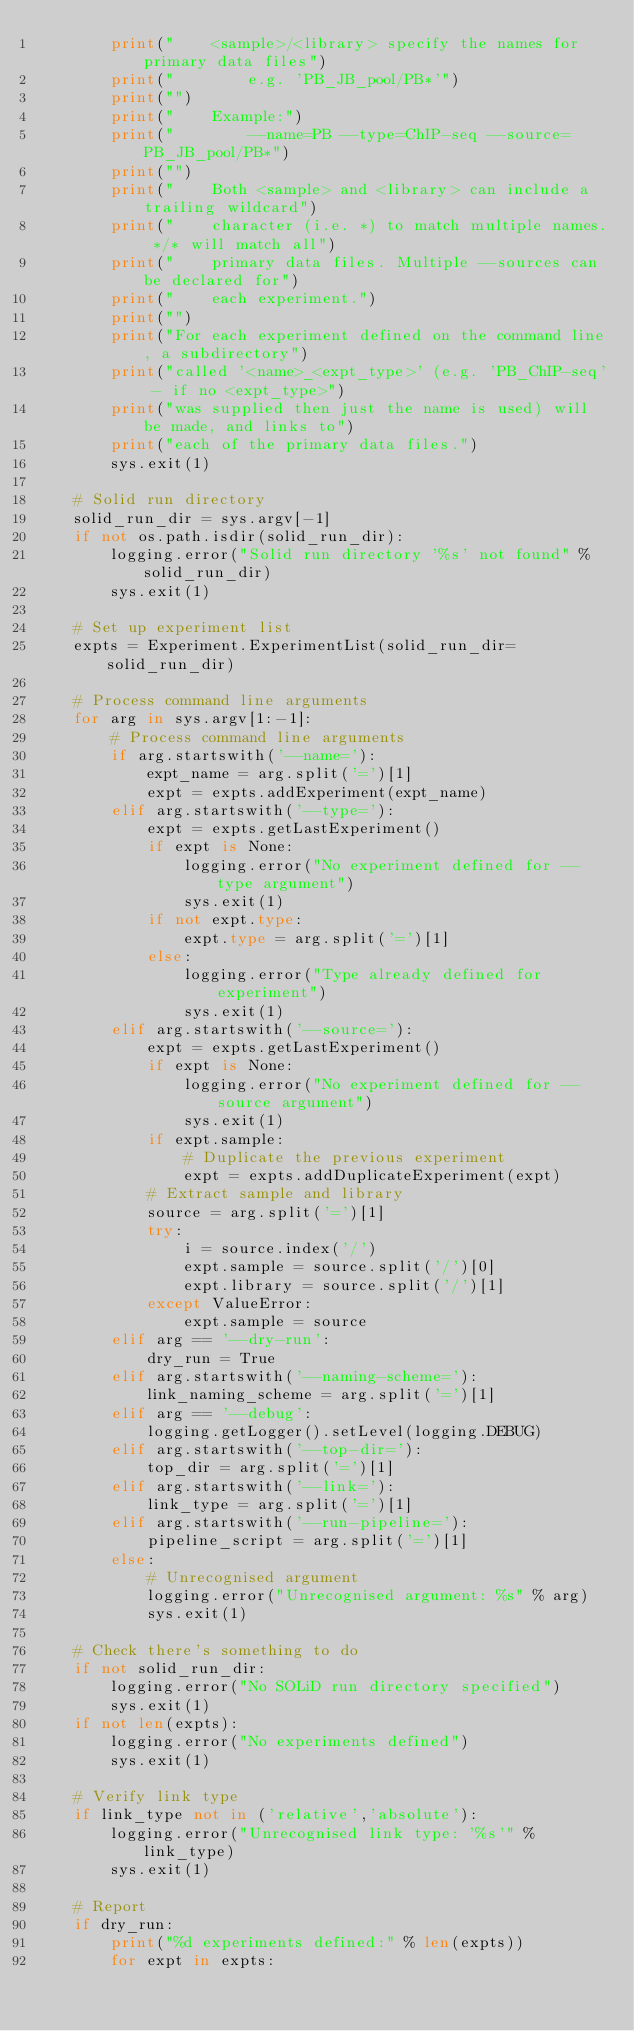Convert code to text. <code><loc_0><loc_0><loc_500><loc_500><_Python_>        print("    <sample>/<library> specify the names for primary data files")
        print("        e.g. 'PB_JB_pool/PB*'")
        print("")
        print("    Example:")
        print("        --name=PB --type=ChIP-seq --source=PB_JB_pool/PB*")
        print("")
        print("    Both <sample> and <library> can include a trailing wildcard")
        print("    character (i.e. *) to match multiple names. */* will match all")
        print("    primary data files. Multiple --sources can be declared for")
        print("    each experiment.")
        print("")
        print("For each experiment defined on the command line, a subdirectory")
        print("called '<name>_<expt_type>' (e.g. 'PB_ChIP-seq' - if no <expt_type>")
        print("was supplied then just the name is used) will be made, and links to")
        print("each of the primary data files.")
        sys.exit(1)

    # Solid run directory
    solid_run_dir = sys.argv[-1]
    if not os.path.isdir(solid_run_dir):
        logging.error("Solid run directory '%s' not found" % solid_run_dir)
        sys.exit(1)

    # Set up experiment list
    expts = Experiment.ExperimentList(solid_run_dir=solid_run_dir)

    # Process command line arguments
    for arg in sys.argv[1:-1]:
        # Process command line arguments
        if arg.startswith('--name='):
            expt_name = arg.split('=')[1]
            expt = expts.addExperiment(expt_name)
        elif arg.startswith('--type='):
            expt = expts.getLastExperiment()
            if expt is None:
                logging.error("No experiment defined for --type argument")
                sys.exit(1)
            if not expt.type:
                expt.type = arg.split('=')[1]
            else:
                logging.error("Type already defined for experiment")
                sys.exit(1)
        elif arg.startswith('--source='):
            expt = expts.getLastExperiment()
            if expt is None:
                logging.error("No experiment defined for --source argument")
                sys.exit(1)
            if expt.sample:
                # Duplicate the previous experiment
                expt = expts.addDuplicateExperiment(expt)
            # Extract sample and library
            source = arg.split('=')[1]
            try:
                i = source.index('/')
                expt.sample = source.split('/')[0]
                expt.library = source.split('/')[1]
            except ValueError:
                expt.sample = source
        elif arg == '--dry-run':
            dry_run = True
        elif arg.startswith('--naming-scheme='):
            link_naming_scheme = arg.split('=')[1]
        elif arg == '--debug':
            logging.getLogger().setLevel(logging.DEBUG)
        elif arg.startswith('--top-dir='):
            top_dir = arg.split('=')[1]
        elif arg.startswith('--link='):
            link_type = arg.split('=')[1]
        elif arg.startswith('--run-pipeline='):
            pipeline_script = arg.split('=')[1]
        else:
            # Unrecognised argument
            logging.error("Unrecognised argument: %s" % arg)
            sys.exit(1)
            
    # Check there's something to do
    if not solid_run_dir:
        logging.error("No SOLiD run directory specified")
        sys.exit(1)
    if not len(expts):
        logging.error("No experiments defined")
        sys.exit(1)

    # Verify link type
    if link_type not in ('relative','absolute'):
        logging.error("Unrecognised link type: '%s'" % link_type)
        sys.exit(1)
    
    # Report
    if dry_run:
        print("%d experiments defined:" % len(expts))
        for expt in expts:</code> 